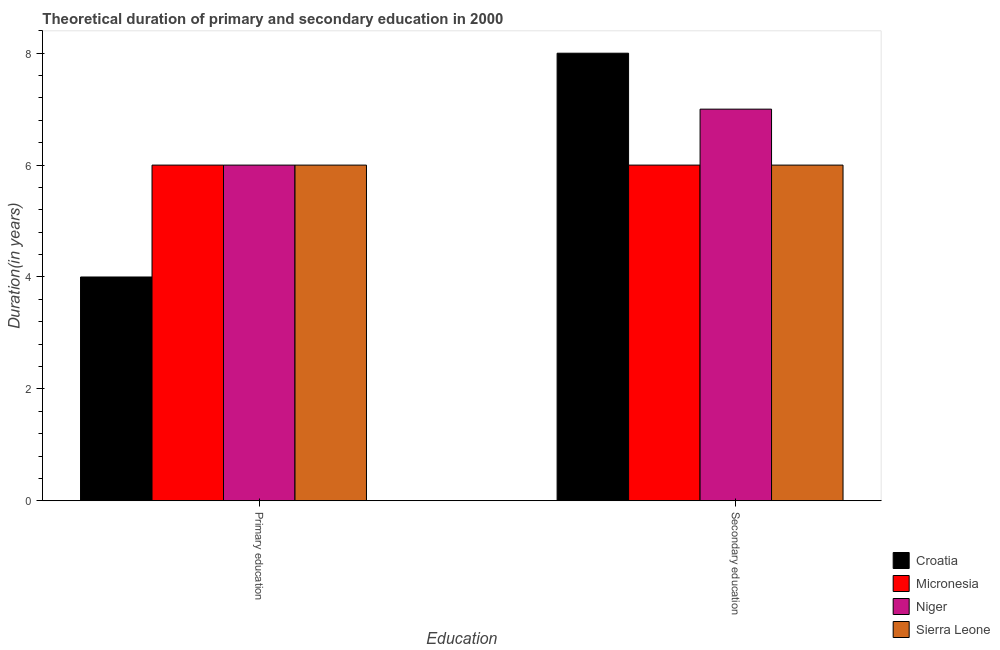How many groups of bars are there?
Make the answer very short. 2. Are the number of bars on each tick of the X-axis equal?
Ensure brevity in your answer.  Yes. How many bars are there on the 2nd tick from the right?
Ensure brevity in your answer.  4. What is the label of the 1st group of bars from the left?
Keep it short and to the point. Primary education. What is the duration of secondary education in Niger?
Provide a short and direct response. 7. Across all countries, what is the maximum duration of secondary education?
Provide a succinct answer. 8. Across all countries, what is the minimum duration of primary education?
Offer a very short reply. 4. In which country was the duration of secondary education maximum?
Keep it short and to the point. Croatia. In which country was the duration of secondary education minimum?
Make the answer very short. Micronesia. What is the total duration of primary education in the graph?
Make the answer very short. 22. What is the difference between the duration of secondary education in Niger and that in Croatia?
Offer a very short reply. -1. What is the difference between the duration of primary education in Croatia and the duration of secondary education in Niger?
Give a very brief answer. -3. What is the difference between the duration of secondary education and duration of primary education in Niger?
Keep it short and to the point. 1. What is the ratio of the duration of secondary education in Sierra Leone to that in Croatia?
Your answer should be very brief. 0.75. Is the duration of primary education in Croatia less than that in Micronesia?
Give a very brief answer. Yes. What does the 3rd bar from the left in Primary education represents?
Keep it short and to the point. Niger. What does the 2nd bar from the right in Secondary education represents?
Ensure brevity in your answer.  Niger. What is the difference between two consecutive major ticks on the Y-axis?
Give a very brief answer. 2. Where does the legend appear in the graph?
Give a very brief answer. Bottom right. How are the legend labels stacked?
Your response must be concise. Vertical. What is the title of the graph?
Your response must be concise. Theoretical duration of primary and secondary education in 2000. What is the label or title of the X-axis?
Your answer should be compact. Education. What is the label or title of the Y-axis?
Offer a very short reply. Duration(in years). What is the Duration(in years) in Croatia in Primary education?
Your answer should be very brief. 4. What is the Duration(in years) of Micronesia in Primary education?
Offer a very short reply. 6. What is the Duration(in years) of Micronesia in Secondary education?
Keep it short and to the point. 6. What is the Duration(in years) of Niger in Secondary education?
Your answer should be very brief. 7. What is the Duration(in years) of Sierra Leone in Secondary education?
Offer a very short reply. 6. Across all Education, what is the maximum Duration(in years) of Croatia?
Provide a short and direct response. 8. Across all Education, what is the minimum Duration(in years) in Croatia?
Make the answer very short. 4. Across all Education, what is the minimum Duration(in years) in Micronesia?
Ensure brevity in your answer.  6. Across all Education, what is the minimum Duration(in years) of Sierra Leone?
Offer a terse response. 6. What is the total Duration(in years) of Croatia in the graph?
Provide a short and direct response. 12. What is the total Duration(in years) in Micronesia in the graph?
Your response must be concise. 12. What is the difference between the Duration(in years) in Micronesia in Primary education and that in Secondary education?
Offer a terse response. 0. What is the difference between the Duration(in years) in Niger in Primary education and that in Secondary education?
Offer a terse response. -1. What is the difference between the Duration(in years) of Sierra Leone in Primary education and that in Secondary education?
Give a very brief answer. 0. What is the difference between the Duration(in years) of Croatia in Primary education and the Duration(in years) of Micronesia in Secondary education?
Provide a succinct answer. -2. What is the difference between the Duration(in years) in Croatia in Primary education and the Duration(in years) in Niger in Secondary education?
Provide a succinct answer. -3. What is the difference between the Duration(in years) in Micronesia in Primary education and the Duration(in years) in Niger in Secondary education?
Your response must be concise. -1. What is the difference between the Duration(in years) of Micronesia in Primary education and the Duration(in years) of Sierra Leone in Secondary education?
Your answer should be very brief. 0. What is the difference between the Duration(in years) in Niger in Primary education and the Duration(in years) in Sierra Leone in Secondary education?
Offer a terse response. 0. What is the average Duration(in years) of Micronesia per Education?
Your answer should be compact. 6. What is the average Duration(in years) of Sierra Leone per Education?
Your answer should be compact. 6. What is the difference between the Duration(in years) of Croatia and Duration(in years) of Micronesia in Primary education?
Your response must be concise. -2. What is the difference between the Duration(in years) in Croatia and Duration(in years) in Sierra Leone in Primary education?
Your answer should be compact. -2. What is the difference between the Duration(in years) of Micronesia and Duration(in years) of Niger in Primary education?
Your answer should be compact. 0. What is the difference between the Duration(in years) in Micronesia and Duration(in years) in Sierra Leone in Primary education?
Your answer should be very brief. 0. What is the difference between the Duration(in years) of Niger and Duration(in years) of Sierra Leone in Primary education?
Your answer should be compact. 0. What is the difference between the Duration(in years) in Croatia and Duration(in years) in Micronesia in Secondary education?
Ensure brevity in your answer.  2. What is the difference between the Duration(in years) of Micronesia and Duration(in years) of Niger in Secondary education?
Keep it short and to the point. -1. What is the difference between the Duration(in years) in Niger and Duration(in years) in Sierra Leone in Secondary education?
Offer a very short reply. 1. What is the ratio of the Duration(in years) in Croatia in Primary education to that in Secondary education?
Make the answer very short. 0.5. What is the ratio of the Duration(in years) of Sierra Leone in Primary education to that in Secondary education?
Your response must be concise. 1. What is the difference between the highest and the second highest Duration(in years) in Niger?
Your response must be concise. 1. What is the difference between the highest and the second highest Duration(in years) in Sierra Leone?
Keep it short and to the point. 0. What is the difference between the highest and the lowest Duration(in years) of Croatia?
Provide a short and direct response. 4. What is the difference between the highest and the lowest Duration(in years) of Sierra Leone?
Your answer should be very brief. 0. 